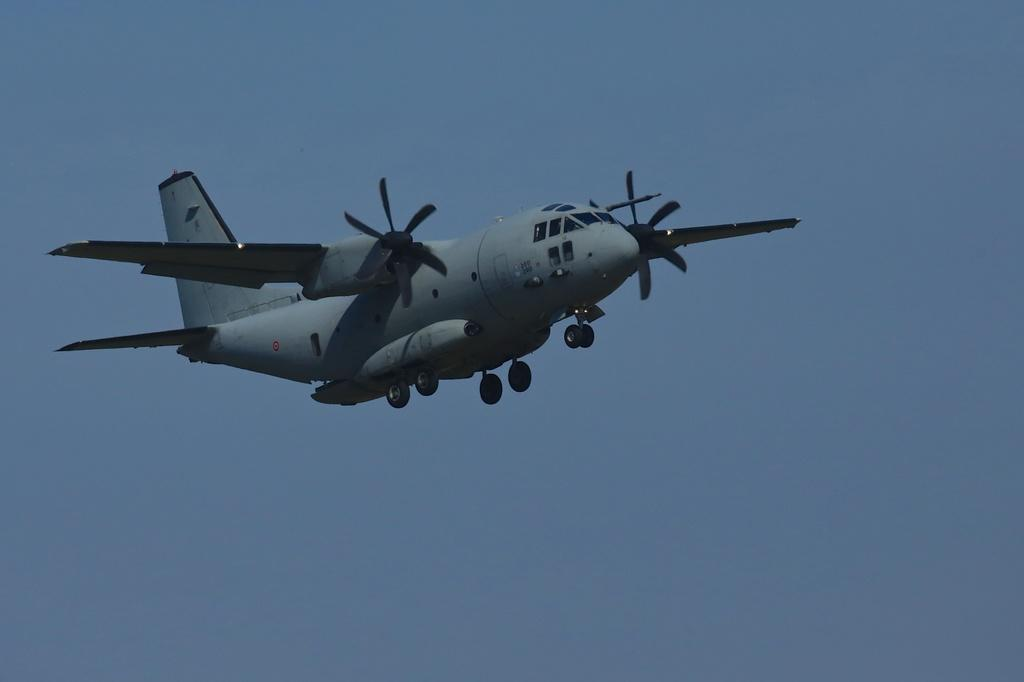What is the main subject of the image? The main subject of the image is an aircraft. What colors can be seen on the aircraft? The aircraft is grey and black in color. What is the aircraft doing in the image? The aircraft is flying in the air. What can be seen in the background of the image? The sky is visible in the background of the image. What type of crayon is being used to draw on the aircraft in the image? There is no crayon or drawing present on the aircraft in the image. 